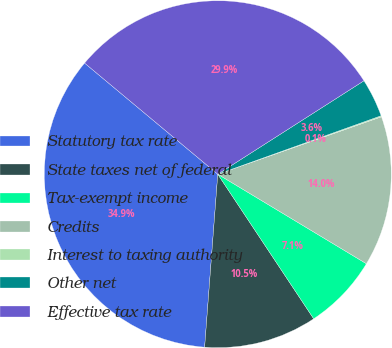<chart> <loc_0><loc_0><loc_500><loc_500><pie_chart><fcel>Statutory tax rate<fcel>State taxes net of federal<fcel>Tax-exempt income<fcel>Credits<fcel>Interest to taxing authority<fcel>Other net<fcel>Effective tax rate<nl><fcel>34.86%<fcel>10.53%<fcel>7.05%<fcel>14.0%<fcel>0.1%<fcel>3.58%<fcel>29.88%<nl></chart> 